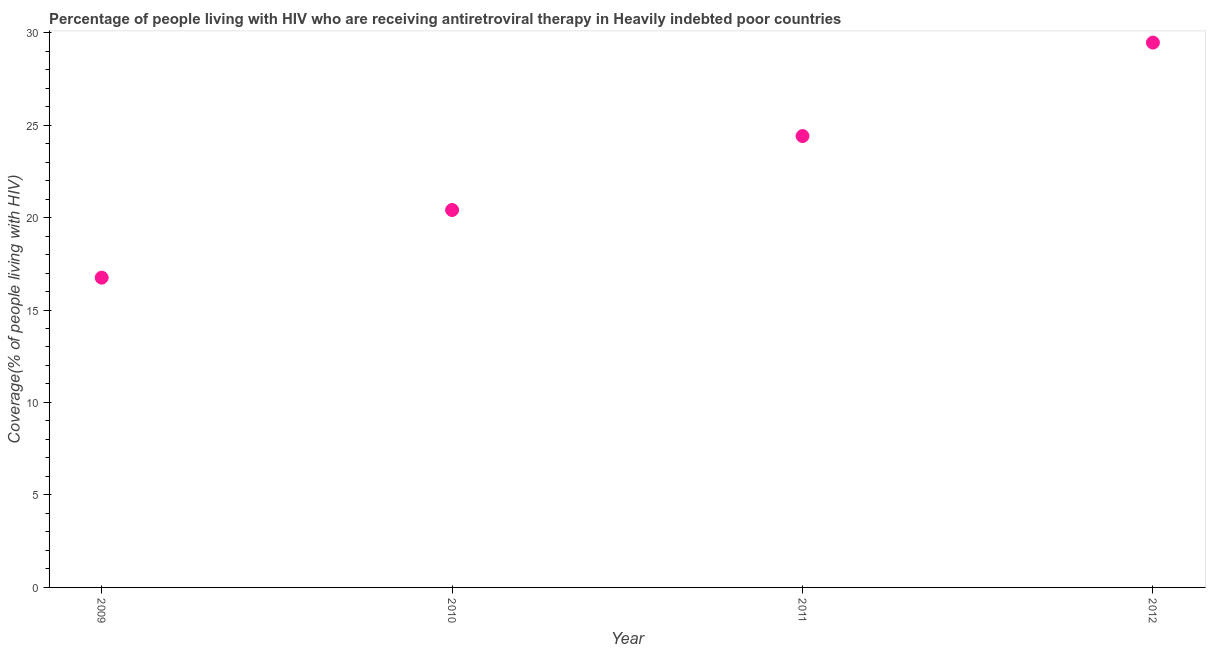What is the antiretroviral therapy coverage in 2010?
Offer a very short reply. 20.41. Across all years, what is the maximum antiretroviral therapy coverage?
Provide a succinct answer. 29.46. Across all years, what is the minimum antiretroviral therapy coverage?
Give a very brief answer. 16.75. In which year was the antiretroviral therapy coverage maximum?
Offer a very short reply. 2012. In which year was the antiretroviral therapy coverage minimum?
Make the answer very short. 2009. What is the sum of the antiretroviral therapy coverage?
Ensure brevity in your answer.  91.02. What is the difference between the antiretroviral therapy coverage in 2009 and 2012?
Offer a terse response. -12.71. What is the average antiretroviral therapy coverage per year?
Provide a succinct answer. 22.76. What is the median antiretroviral therapy coverage?
Provide a succinct answer. 22.41. In how many years, is the antiretroviral therapy coverage greater than 1 %?
Provide a succinct answer. 4. What is the ratio of the antiretroviral therapy coverage in 2010 to that in 2012?
Your answer should be compact. 0.69. Is the antiretroviral therapy coverage in 2009 less than that in 2010?
Make the answer very short. Yes. Is the difference between the antiretroviral therapy coverage in 2009 and 2011 greater than the difference between any two years?
Keep it short and to the point. No. What is the difference between the highest and the second highest antiretroviral therapy coverage?
Make the answer very short. 5.05. Is the sum of the antiretroviral therapy coverage in 2010 and 2012 greater than the maximum antiretroviral therapy coverage across all years?
Keep it short and to the point. Yes. What is the difference between the highest and the lowest antiretroviral therapy coverage?
Offer a terse response. 12.71. Does the antiretroviral therapy coverage monotonically increase over the years?
Ensure brevity in your answer.  Yes. How many dotlines are there?
Provide a succinct answer. 1. How many years are there in the graph?
Give a very brief answer. 4. Are the values on the major ticks of Y-axis written in scientific E-notation?
Offer a very short reply. No. Does the graph contain any zero values?
Offer a terse response. No. Does the graph contain grids?
Offer a very short reply. No. What is the title of the graph?
Ensure brevity in your answer.  Percentage of people living with HIV who are receiving antiretroviral therapy in Heavily indebted poor countries. What is the label or title of the X-axis?
Your answer should be compact. Year. What is the label or title of the Y-axis?
Your answer should be very brief. Coverage(% of people living with HIV). What is the Coverage(% of people living with HIV) in 2009?
Provide a short and direct response. 16.75. What is the Coverage(% of people living with HIV) in 2010?
Provide a short and direct response. 20.41. What is the Coverage(% of people living with HIV) in 2011?
Ensure brevity in your answer.  24.41. What is the Coverage(% of people living with HIV) in 2012?
Your answer should be very brief. 29.46. What is the difference between the Coverage(% of people living with HIV) in 2009 and 2010?
Offer a very short reply. -3.66. What is the difference between the Coverage(% of people living with HIV) in 2009 and 2011?
Ensure brevity in your answer.  -7.66. What is the difference between the Coverage(% of people living with HIV) in 2009 and 2012?
Provide a succinct answer. -12.71. What is the difference between the Coverage(% of people living with HIV) in 2010 and 2011?
Your response must be concise. -4. What is the difference between the Coverage(% of people living with HIV) in 2010 and 2012?
Ensure brevity in your answer.  -9.05. What is the difference between the Coverage(% of people living with HIV) in 2011 and 2012?
Provide a short and direct response. -5.05. What is the ratio of the Coverage(% of people living with HIV) in 2009 to that in 2010?
Your response must be concise. 0.82. What is the ratio of the Coverage(% of people living with HIV) in 2009 to that in 2011?
Provide a succinct answer. 0.69. What is the ratio of the Coverage(% of people living with HIV) in 2009 to that in 2012?
Offer a very short reply. 0.57. What is the ratio of the Coverage(% of people living with HIV) in 2010 to that in 2011?
Offer a terse response. 0.84. What is the ratio of the Coverage(% of people living with HIV) in 2010 to that in 2012?
Ensure brevity in your answer.  0.69. What is the ratio of the Coverage(% of people living with HIV) in 2011 to that in 2012?
Your answer should be compact. 0.83. 